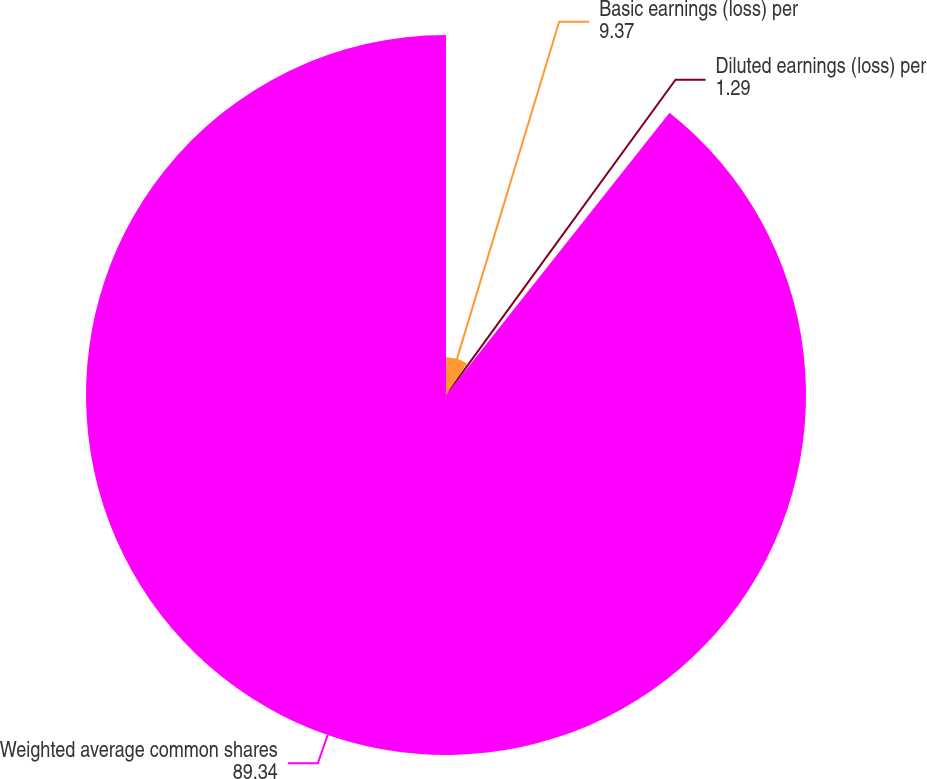<chart> <loc_0><loc_0><loc_500><loc_500><pie_chart><fcel>Basic earnings (loss) per<fcel>Diluted earnings (loss) per<fcel>Weighted average common shares<nl><fcel>9.37%<fcel>1.29%<fcel>89.34%<nl></chart> 